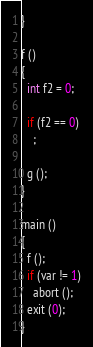<code> <loc_0><loc_0><loc_500><loc_500><_C_>}

f ()
{
  int f2 = 0;

  if (f2 == 0)
    ;

  g ();
}

main ()
{
  f ();
  if (var != 1)
    abort ();
  exit (0);
}
</code> 